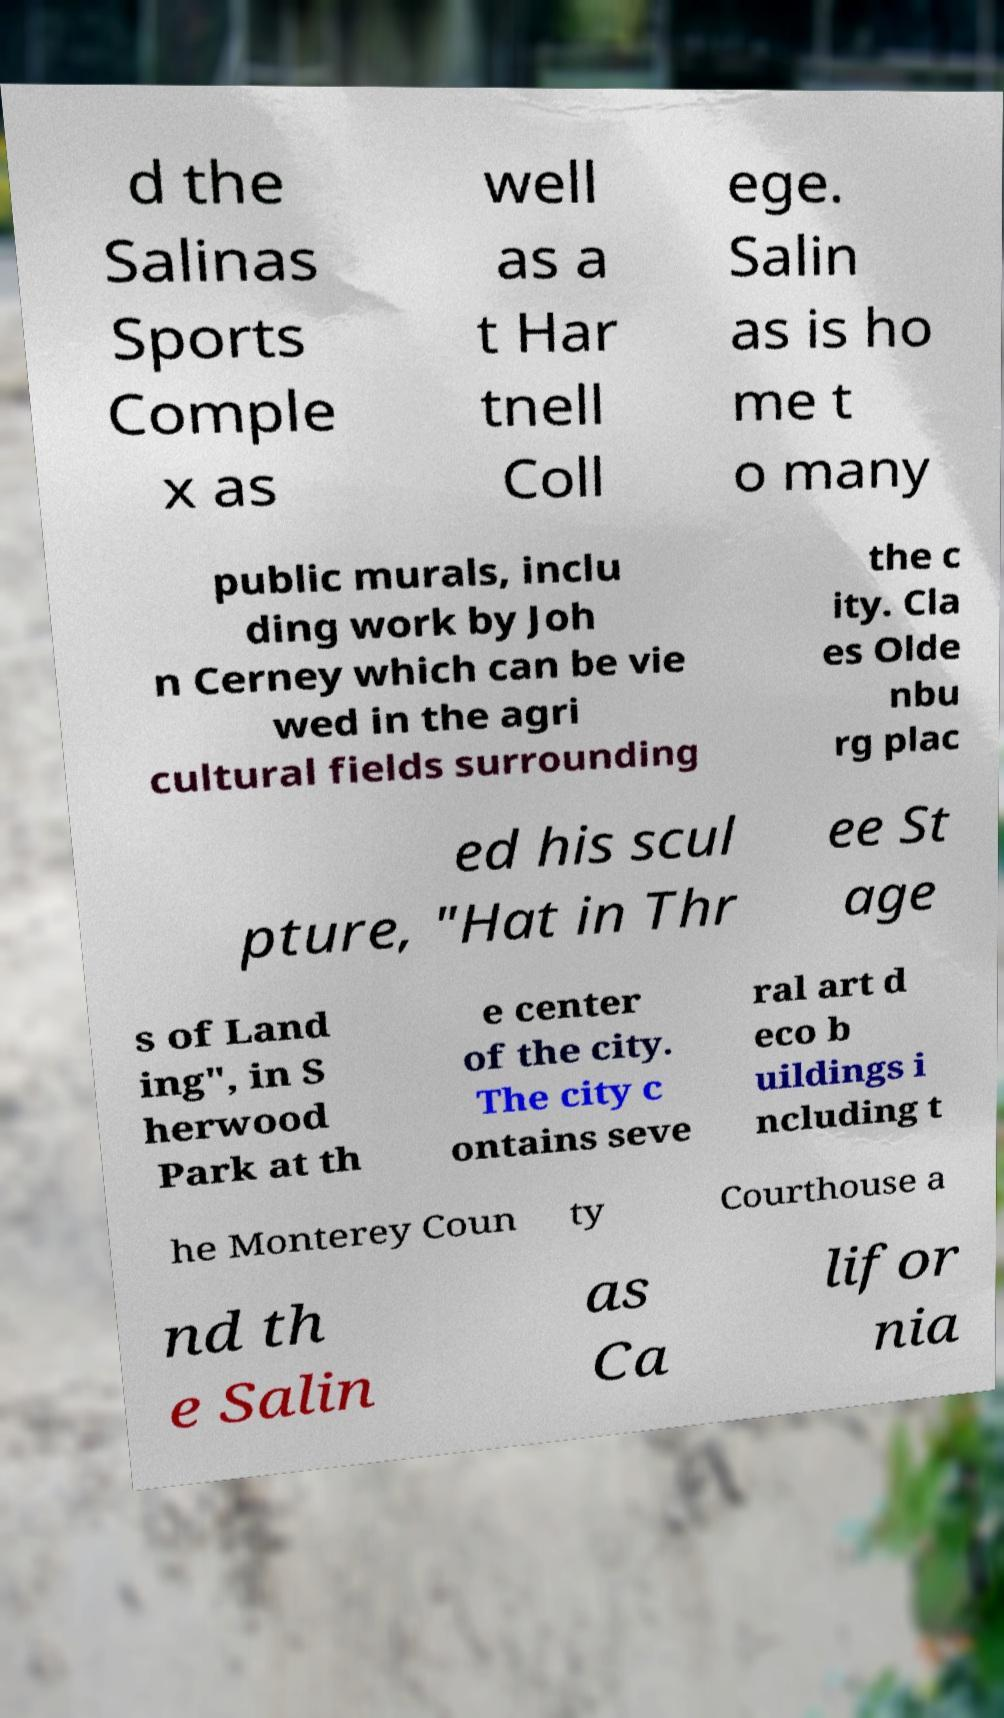Please read and relay the text visible in this image. What does it say? d the Salinas Sports Comple x as well as a t Har tnell Coll ege. Salin as is ho me t o many public murals, inclu ding work by Joh n Cerney which can be vie wed in the agri cultural fields surrounding the c ity. Cla es Olde nbu rg plac ed his scul pture, "Hat in Thr ee St age s of Land ing", in S herwood Park at th e center of the city. The city c ontains seve ral art d eco b uildings i ncluding t he Monterey Coun ty Courthouse a nd th e Salin as Ca lifor nia 